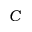<formula> <loc_0><loc_0><loc_500><loc_500>C</formula> 